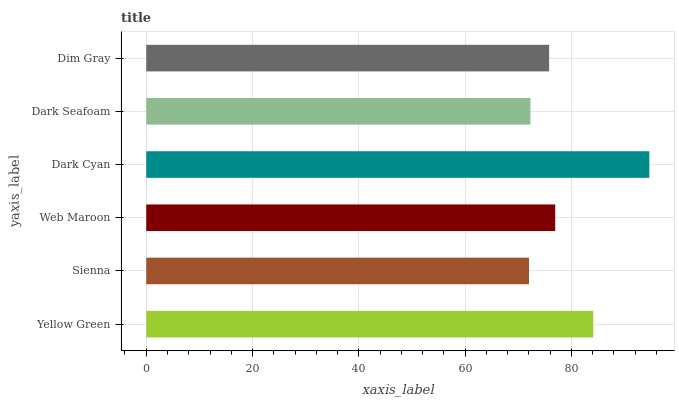Is Sienna the minimum?
Answer yes or no. Yes. Is Dark Cyan the maximum?
Answer yes or no. Yes. Is Web Maroon the minimum?
Answer yes or no. No. Is Web Maroon the maximum?
Answer yes or no. No. Is Web Maroon greater than Sienna?
Answer yes or no. Yes. Is Sienna less than Web Maroon?
Answer yes or no. Yes. Is Sienna greater than Web Maroon?
Answer yes or no. No. Is Web Maroon less than Sienna?
Answer yes or no. No. Is Web Maroon the high median?
Answer yes or no. Yes. Is Dim Gray the low median?
Answer yes or no. Yes. Is Dark Seafoam the high median?
Answer yes or no. No. Is Sienna the low median?
Answer yes or no. No. 